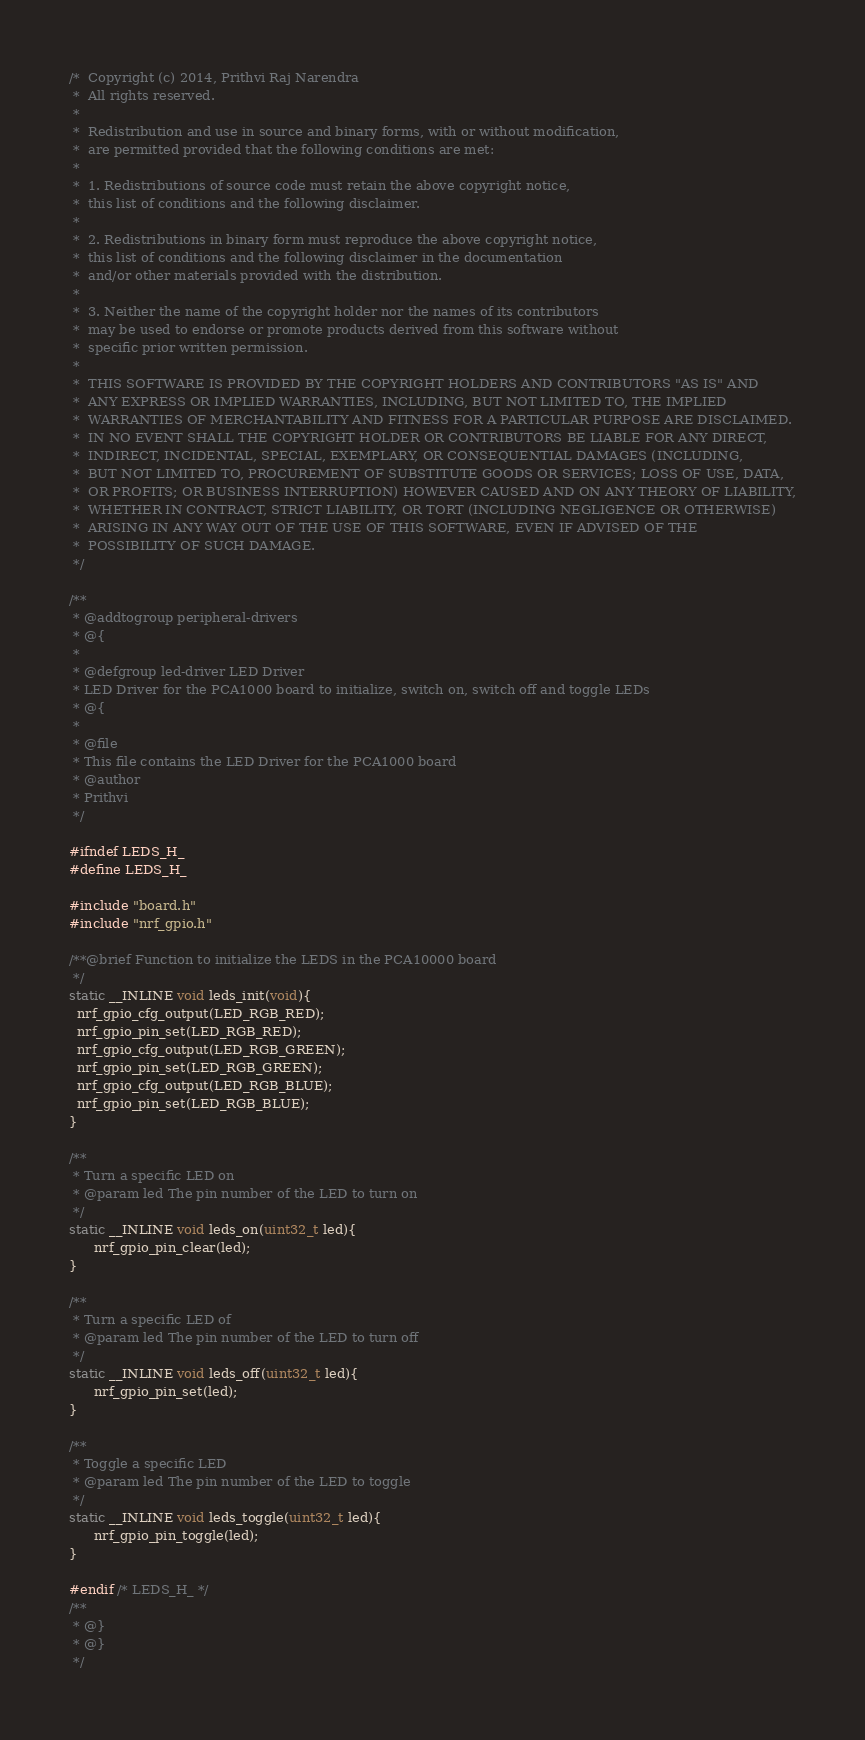<code> <loc_0><loc_0><loc_500><loc_500><_C_>/* 	Copyright (c) 2014, Prithvi Raj Narendra
 *	All rights reserved.
 *
 *	Redistribution and use in source and binary forms, with or without modification,
 *	are permitted provided that the following conditions are met:
 *
 *	1. Redistributions of source code must retain the above copyright notice,
 *	this list of conditions and the following disclaimer.
 *
 *	2. Redistributions in binary form must reproduce the above copyright notice,
 *	this list of conditions and the following disclaimer in the documentation
 *	and/or other materials provided with the distribution.
 *
 *	3. Neither the name of the copyright holder nor the names of its contributors
 *	may be used to endorse or promote products derived from this software without
 *	specific prior written permission.
 *
 *	THIS SOFTWARE IS PROVIDED BY THE COPYRIGHT HOLDERS AND CONTRIBUTORS "AS IS" AND
 *	ANY EXPRESS OR IMPLIED WARRANTIES, INCLUDING, BUT NOT LIMITED TO, THE IMPLIED
 *	WARRANTIES OF MERCHANTABILITY AND FITNESS FOR A PARTICULAR PURPOSE ARE DISCLAIMED.
 *	IN NO EVENT SHALL THE COPYRIGHT HOLDER OR CONTRIBUTORS BE LIABLE FOR ANY DIRECT,
 *	INDIRECT, INCIDENTAL, SPECIAL, EXEMPLARY, OR CONSEQUENTIAL DAMAGES (INCLUDING,
 *	BUT NOT LIMITED TO, PROCUREMENT OF SUBSTITUTE GOODS OR SERVICES; LOSS OF USE, DATA,
 *	OR PROFITS; OR BUSINESS INTERRUPTION) HOWEVER CAUSED AND ON ANY THEORY OF LIABILITY,
 *	WHETHER IN CONTRACT, STRICT LIABILITY, OR TORT (INCLUDING NEGLIGENCE OR OTHERWISE)
 *	ARISING IN ANY WAY OUT OF THE USE OF THIS SOFTWARE, EVEN IF ADVISED OF THE
 *	POSSIBILITY OF SUCH DAMAGE.
 */

/**
 * @addtogroup peripheral-drivers
 * @{
 *
 * @defgroup led-driver LED Driver
 * LED Driver for the PCA1000 board to initialize, switch on, switch off and toggle LEDs
 * @{
 *
 * @file
 * This file contains the LED Driver for the PCA1000 board
 * @author
 * Prithvi
 */

#ifndef LEDS_H_
#define LEDS_H_

#include "board.h"
#include "nrf_gpio.h"

/**@brief Function to initialize the LEDS in the PCA10000 board
 */
static __INLINE void leds_init(void){
  nrf_gpio_cfg_output(LED_RGB_RED);
  nrf_gpio_pin_set(LED_RGB_RED);
  nrf_gpio_cfg_output(LED_RGB_GREEN);
  nrf_gpio_pin_set(LED_RGB_GREEN);
  nrf_gpio_cfg_output(LED_RGB_BLUE);
  nrf_gpio_pin_set(LED_RGB_BLUE);
}

/**
 * Turn a specific LED on
 * @param led The pin number of the LED to turn on
 */
static __INLINE void leds_on(uint32_t led){
	  nrf_gpio_pin_clear(led);
}

/**
 * Turn a specific LED of
 * @param led The pin number of the LED to turn off
 */
static __INLINE void leds_off(uint32_t led){
	  nrf_gpio_pin_set(led);
}

/**
 * Toggle a specific LED
 * @param led The pin number of the LED to toggle
 */
static __INLINE void leds_toggle(uint32_t led){
	  nrf_gpio_pin_toggle(led);
}

#endif /* LEDS_H_ */
/**
 * @}
 * @}
 */
</code> 